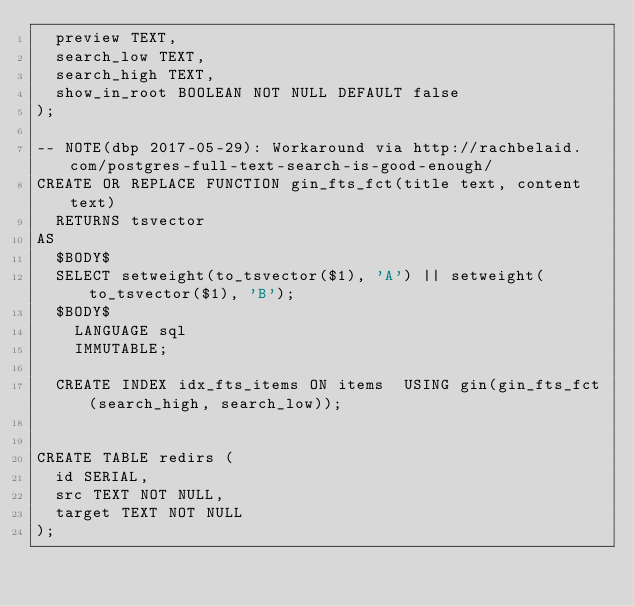Convert code to text. <code><loc_0><loc_0><loc_500><loc_500><_SQL_>  preview TEXT,
  search_low TEXT,
  search_high TEXT,
  show_in_root BOOLEAN NOT NULL DEFAULT false
);

-- NOTE(dbp 2017-05-29): Workaround via http://rachbelaid.com/postgres-full-text-search-is-good-enough/
CREATE OR REPLACE FUNCTION gin_fts_fct(title text, content text)
  RETURNS tsvector
AS
  $BODY$
  SELECT setweight(to_tsvector($1), 'A') || setweight(to_tsvector($1), 'B');
  $BODY$
    LANGUAGE sql
    IMMUTABLE;

  CREATE INDEX idx_fts_items ON items  USING gin(gin_fts_fct(search_high, search_low));


CREATE TABLE redirs (
  id SERIAL,
  src TEXT NOT NULL,
  target TEXT NOT NULL
);

</code> 